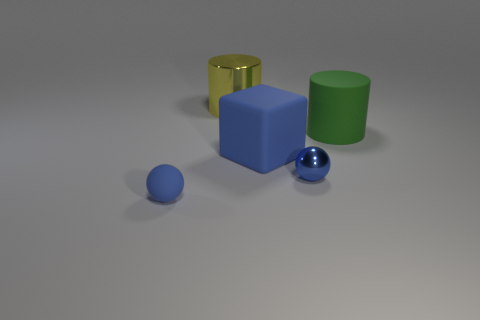Add 5 big blue rubber blocks. How many objects exist? 10 Subtract all spheres. How many objects are left? 3 Subtract 1 blue cubes. How many objects are left? 4 Subtract all matte blocks. Subtract all big green matte things. How many objects are left? 3 Add 1 big blue matte cubes. How many big blue matte cubes are left? 2 Add 3 yellow metal objects. How many yellow metal objects exist? 4 